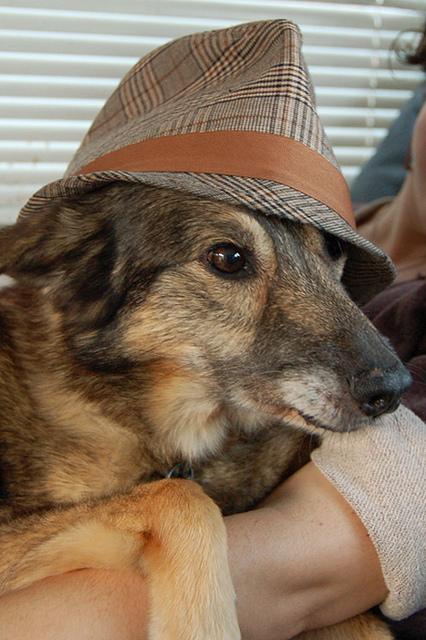Is the dog a poodle?
Quick response, please. No. What type of hat is on the dog?
Short answer required. Fedora. Are the blinds open or closed?
Answer briefly. Closed. 